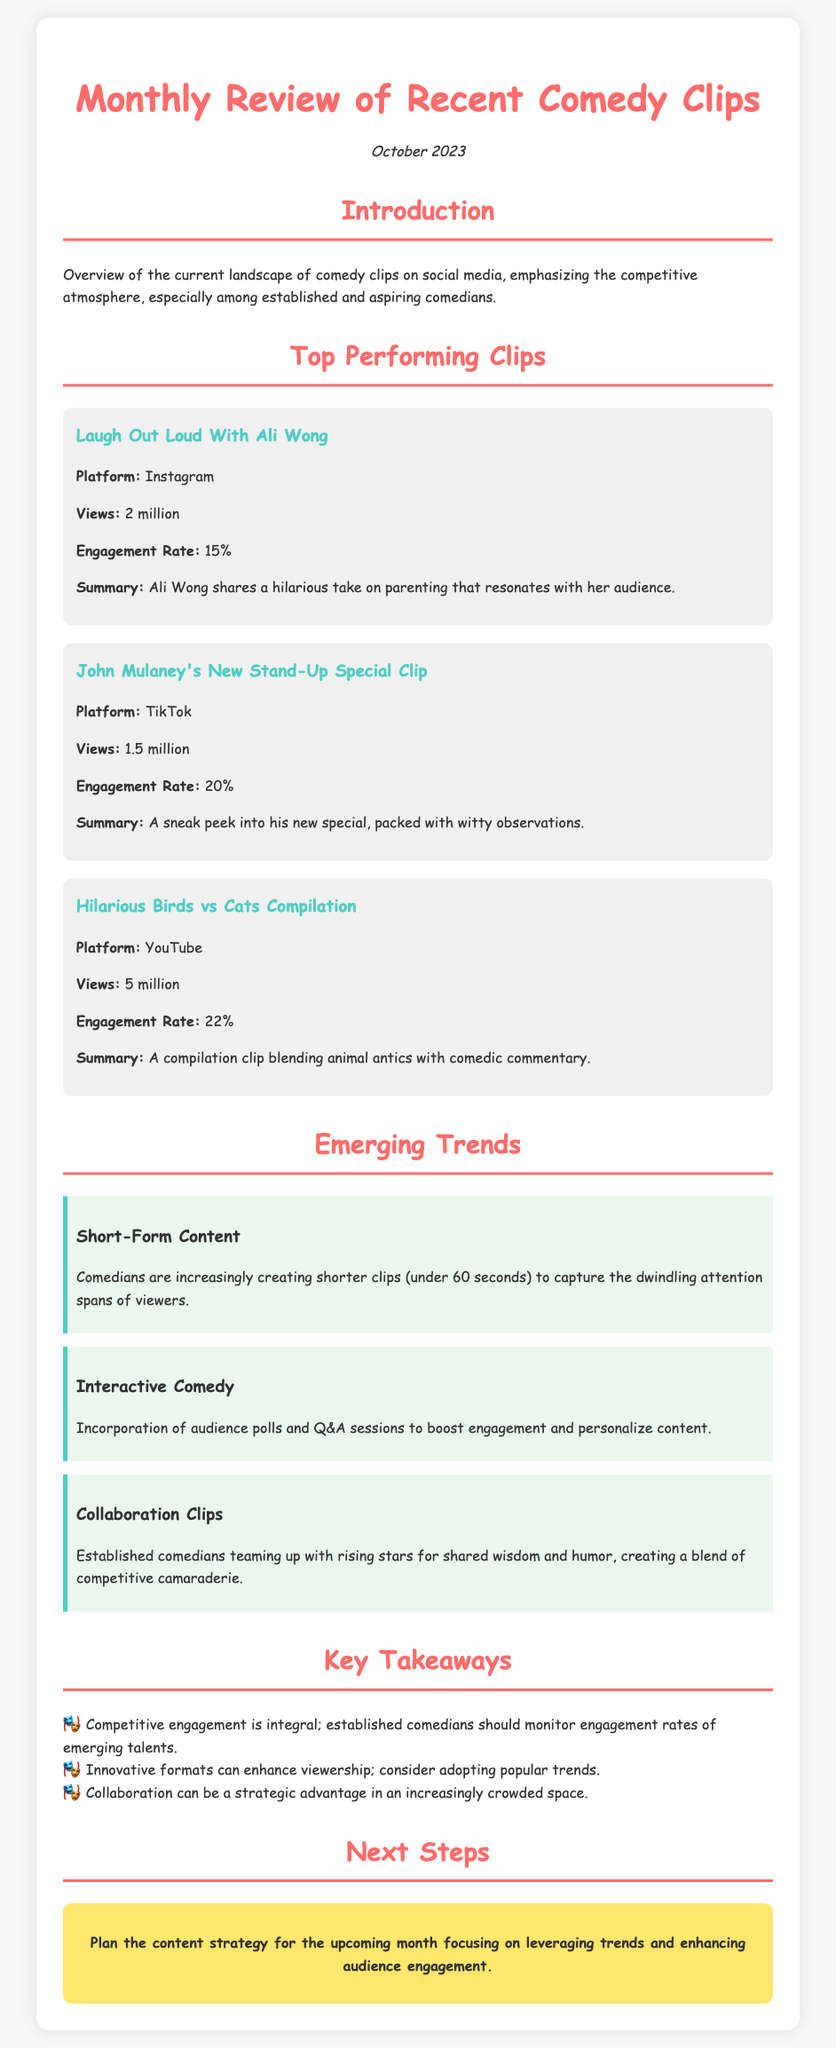What is the title of the document? The title of the document is found in the header section, which states "Monthly Review of Recent Comedy Clips."
Answer: Monthly Review of Recent Comedy Clips How many views did the "Hilarious Birds vs Cats Compilation" receive? The view count for "Hilarious Birds vs Cats Compilation" is stated in the respective clip section, which shows 5 million views.
Answer: 5 million What is the engagement rate of John Mulaney's clip? The engagement rate for John Mulaney's clip is mentioned in the clip section, which indicates 20%.
Answer: 20% What is one emerging trend mentioned in the document? The document highlights multiple trends; one of them is "Short-Form Content."
Answer: Short-Form Content Which platform had the highest viewed clip? The document provides details on the platforms for each clip, identifying that YouTube had the highest views at 5 million.
Answer: YouTube What date is mentioned in the document? The date is stylishly displayed and is stated as "October 2023."
Answer: October 2023 What is one key takeaway from the document? The document outlines several key takeaways; one of them states that competitive engagement is integral.
Answer: Competitive engagement is integral What is the type of humor featured in Ali Wong's clip? The summary of Ali Wong's clip describes it as relating to "parenting," indicating the type of humor.
Answer: Parenting What strategic advantage is mentioned in the next steps? The next steps emphasize enhancing audience engagement, suggesting a strategic advantage.
Answer: Enhancing audience engagement 